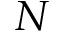Convert formula to latex. <formula><loc_0><loc_0><loc_500><loc_500>N</formula> 